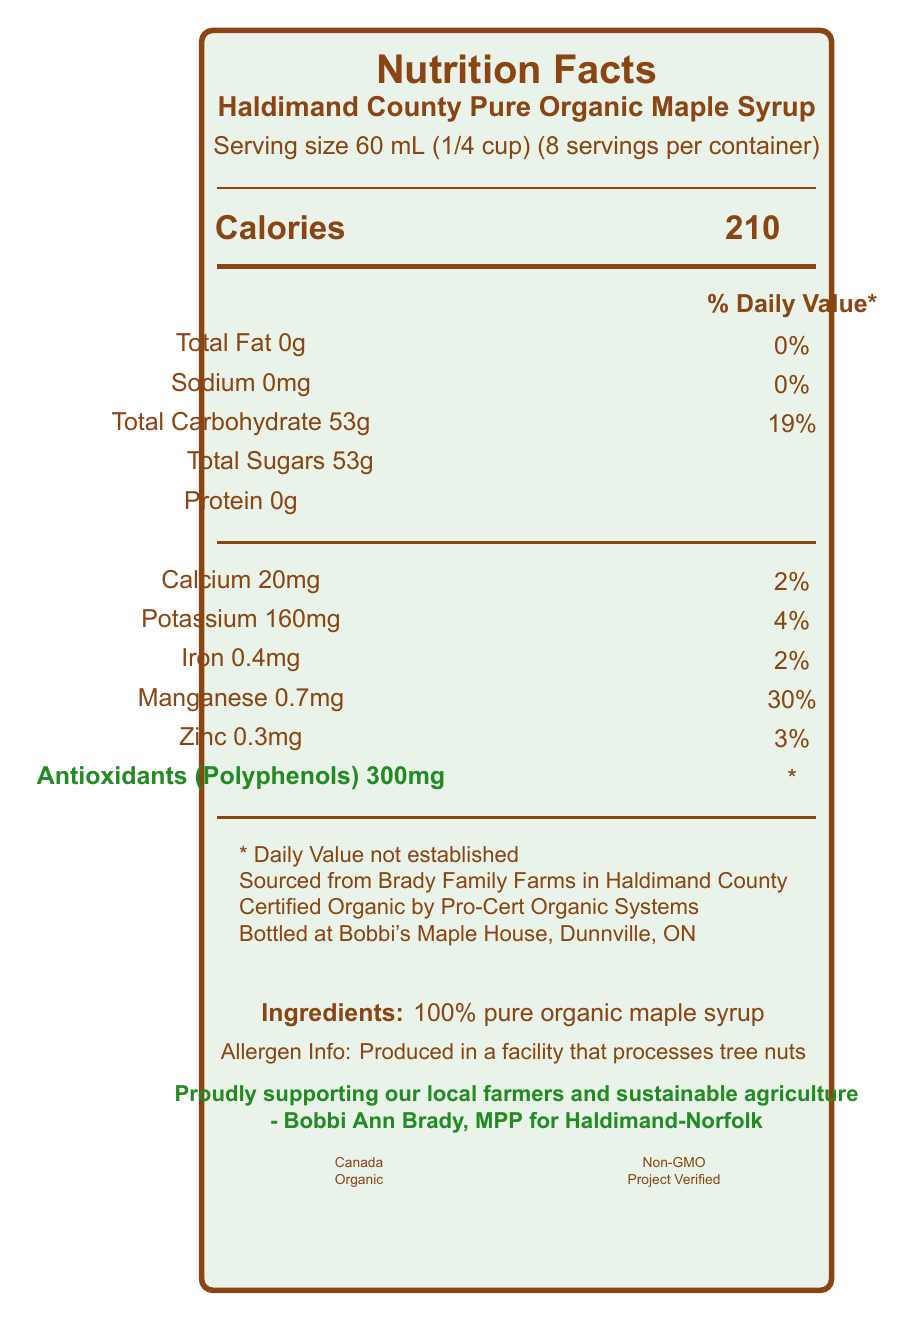what is the serving size for the maple syrup? The serving size is clearly specified as 60 mL (1/4 cup) in the document.
Answer: 60 mL (1/4 cup) how many calories are in one serving of the maple syrup? The document lists 210 calories for one serving.
Answer: 210 what is the daily value percentage for manganese? The document explicitly states that manganese has a daily value of 30%.
Answer: 30% does this maple syrup contain any sodium? The document lists 0mg of sodium with a daily value of 0%.
Answer: No where is the maple syrup sourced from? The additional information section indicates it is sourced from Brady Family Farms in Haldimand County.
Answer: Brady Family Farms in Haldimand County which of the following nutrients is present in the highest amount per serving? A. Calcium B. Iron C. Potassium D. Zinc Potassium is present in the amount of 160 mg per serving, which is higher than calcium (20 mg), iron (0.4 mg), and zinc (0.3 mg).
Answer: C: Potassium what is the certification status of the maple syrup? A. Non-GMO only B. Organic only C. Both Non-GMO and Organic D. Neither The document shows certification logos for both "Canada Organic" and "Non-GMO Project Verified."
Answer: C: Both Non-GMO and Organic is the amount of antioxidants daily value established? The document clearly states that the daily value for antioxidants is not established.
Answer: No describe the main idea of this document. The document includes nutritional facts such as serving size, calories, and various nutrients. It additionally provides certification information, sourcing details, and a note on allergens. It also highlights the endorsement by Bobbi Ann Brady.
Answer: The document provides the nutritional information for Haldimand County Pure Organic Maple Syrup, including details on serving size, calories, specific nutrients, and additional information on sourcing, certification, and allergen warnings. It also highlights that the syrup contains 300mg of antioxidants per serving. who endorses the Haldimand County Pure Organic Maple Syrup? The document contains an endorsement from Bobbi Ann Brady, MPP for Haldimand-Norfolk.
Answer: Bobbi Ann Brady what is the amount of calcium in one serving? The document lists 20mg of calcium per serving.
Answer: 20mg can this product be considered a source of protein? The document indicates that the amount of protein in one serving is 0g.
Answer: No does this maple syrup contain any fiber? The document does not mention fiber content, so it cannot be determined.
Answer: Not enough information how much total sugar is in one serving? The document lists 53g of total sugars in one serving.
Answer: 53g is the maple syrup produced in a facility that processes dairy? The document only mentions that it is produced in a facility that processes tree nuts. No information about dairy is provided.
Answer: Cannot be determined 